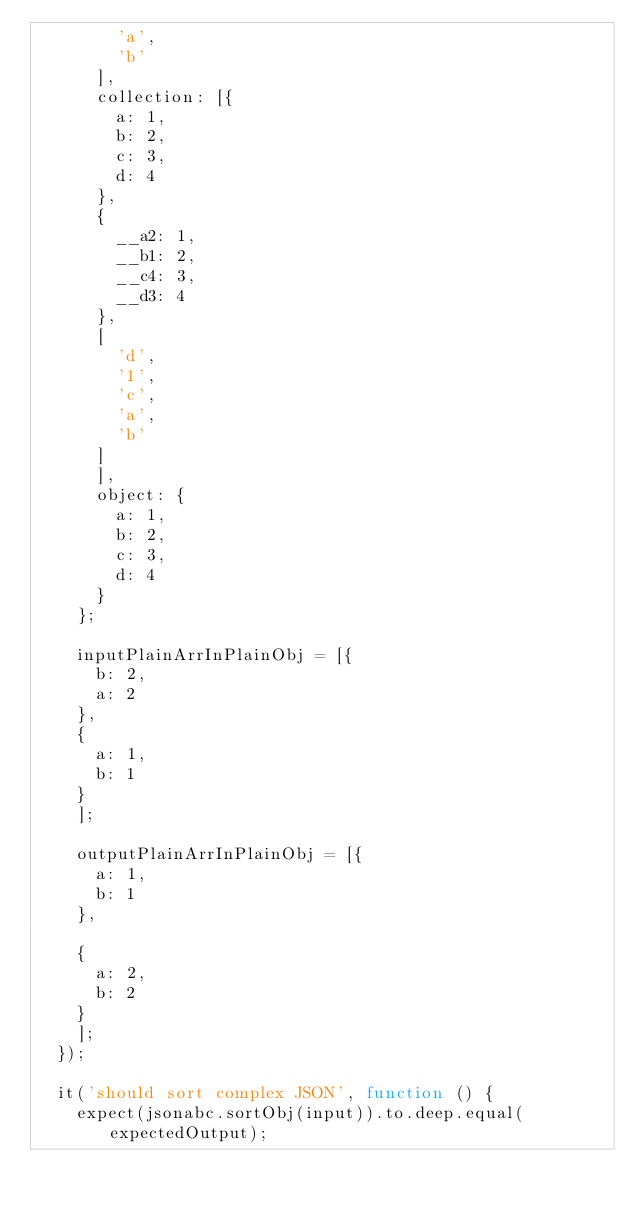Convert code to text. <code><loc_0><loc_0><loc_500><loc_500><_JavaScript_>        'a',
        'b'
      ],
      collection: [{
        a: 1,
        b: 2,
        c: 3,
        d: 4
      },
      {
        __a2: 1,
        __b1: 2,
        __c4: 3,
        __d3: 4
      },
      [
        'd',
        '1',
        'c',
        'a',
        'b'
      ]
      ],
      object: {
        a: 1,
        b: 2,
        c: 3,
        d: 4
      }
    };

    inputPlainArrInPlainObj = [{
      b: 2,
      a: 2
    },
    {
      a: 1,
      b: 1
    }
    ];

    outputPlainArrInPlainObj = [{
      a: 1,
      b: 1
    },

    {
      a: 2,
      b: 2
    }
    ];
  });

  it('should sort complex JSON', function () {
    expect(jsonabc.sortObj(input)).to.deep.equal(expectedOutput);</code> 